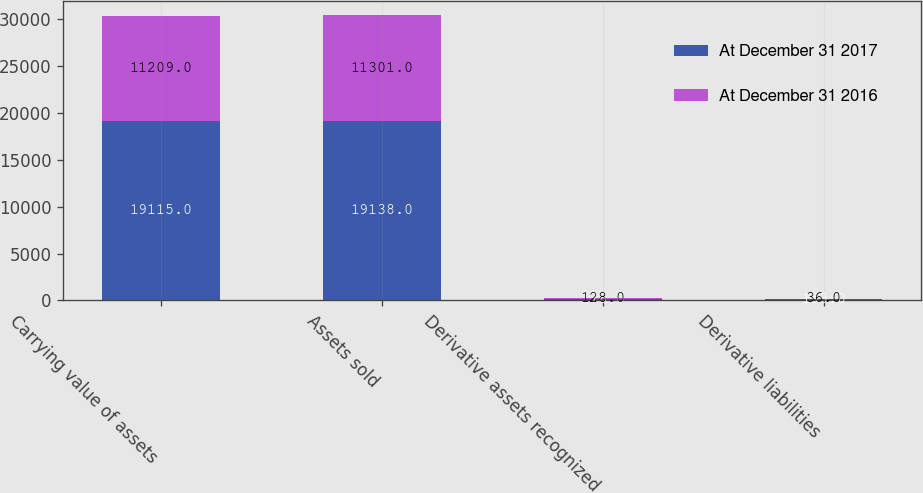Convert chart to OTSL. <chart><loc_0><loc_0><loc_500><loc_500><stacked_bar_chart><ecel><fcel>Carrying value of assets<fcel>Assets sold<fcel>Derivative assets recognized<fcel>Derivative liabilities<nl><fcel>At December 31 2017<fcel>19115<fcel>19138<fcel>176<fcel>153<nl><fcel>At December 31 2016<fcel>11209<fcel>11301<fcel>128<fcel>36<nl></chart> 